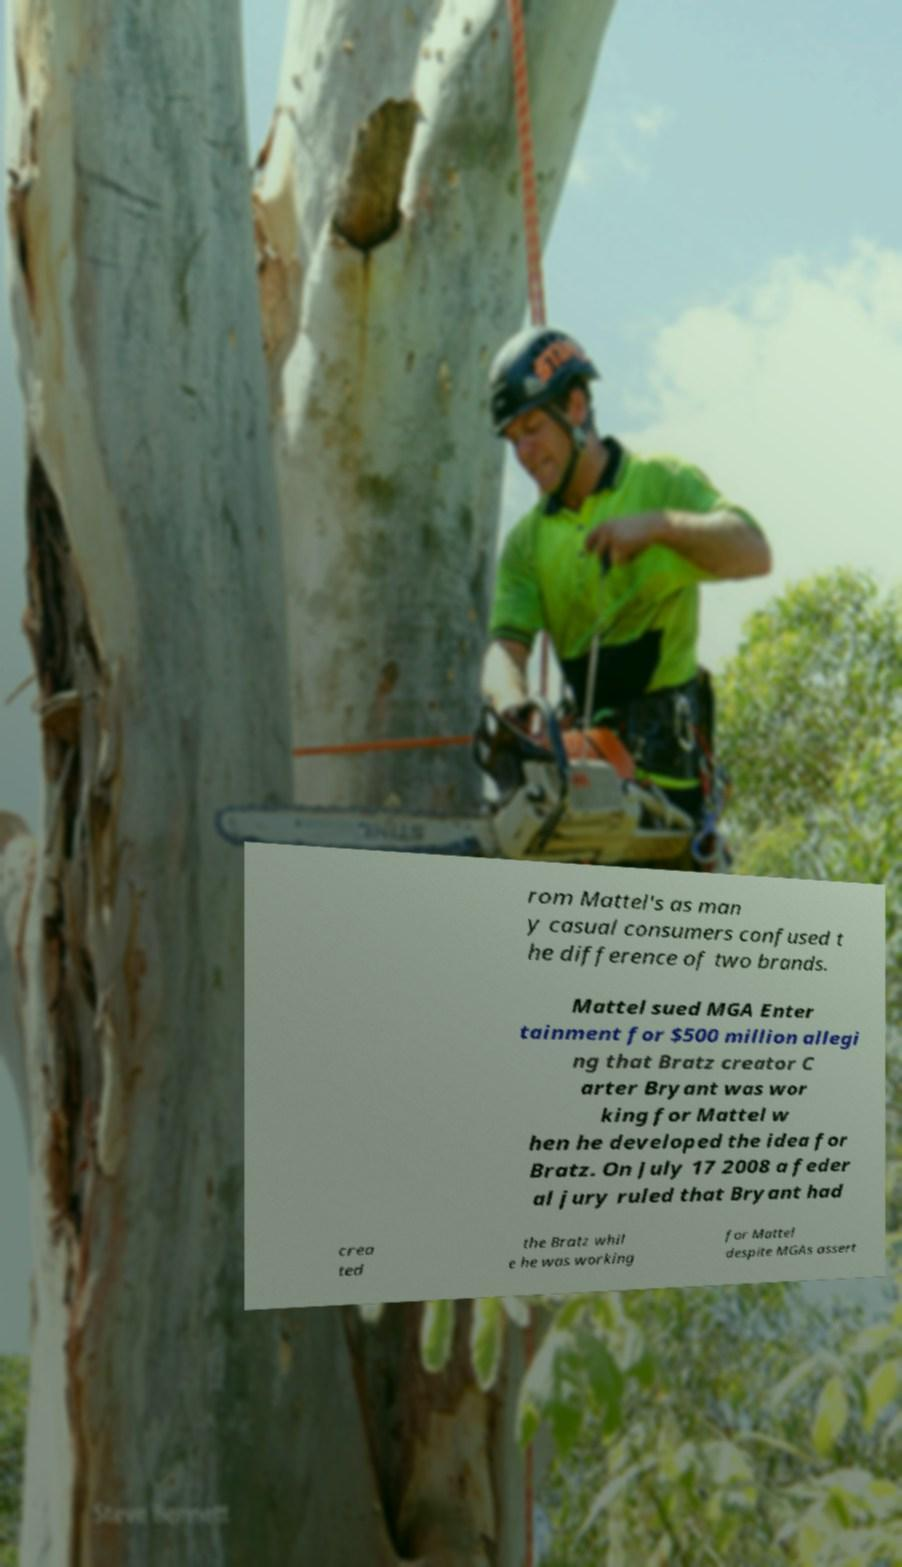There's text embedded in this image that I need extracted. Can you transcribe it verbatim? rom Mattel's as man y casual consumers confused t he difference of two brands. Mattel sued MGA Enter tainment for $500 million allegi ng that Bratz creator C arter Bryant was wor king for Mattel w hen he developed the idea for Bratz. On July 17 2008 a feder al jury ruled that Bryant had crea ted the Bratz whil e he was working for Mattel despite MGAs assert 